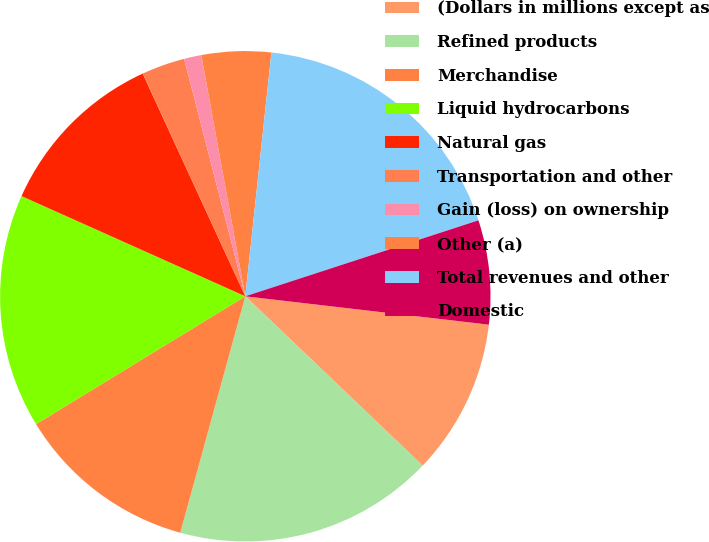<chart> <loc_0><loc_0><loc_500><loc_500><pie_chart><fcel>(Dollars in millions except as<fcel>Refined products<fcel>Merchandise<fcel>Liquid hydrocarbons<fcel>Natural gas<fcel>Transportation and other<fcel>Gain (loss) on ownership<fcel>Other (a)<fcel>Total revenues and other<fcel>Domestic<nl><fcel>10.29%<fcel>17.14%<fcel>12.0%<fcel>15.43%<fcel>11.43%<fcel>2.86%<fcel>1.14%<fcel>4.57%<fcel>18.29%<fcel>6.86%<nl></chart> 